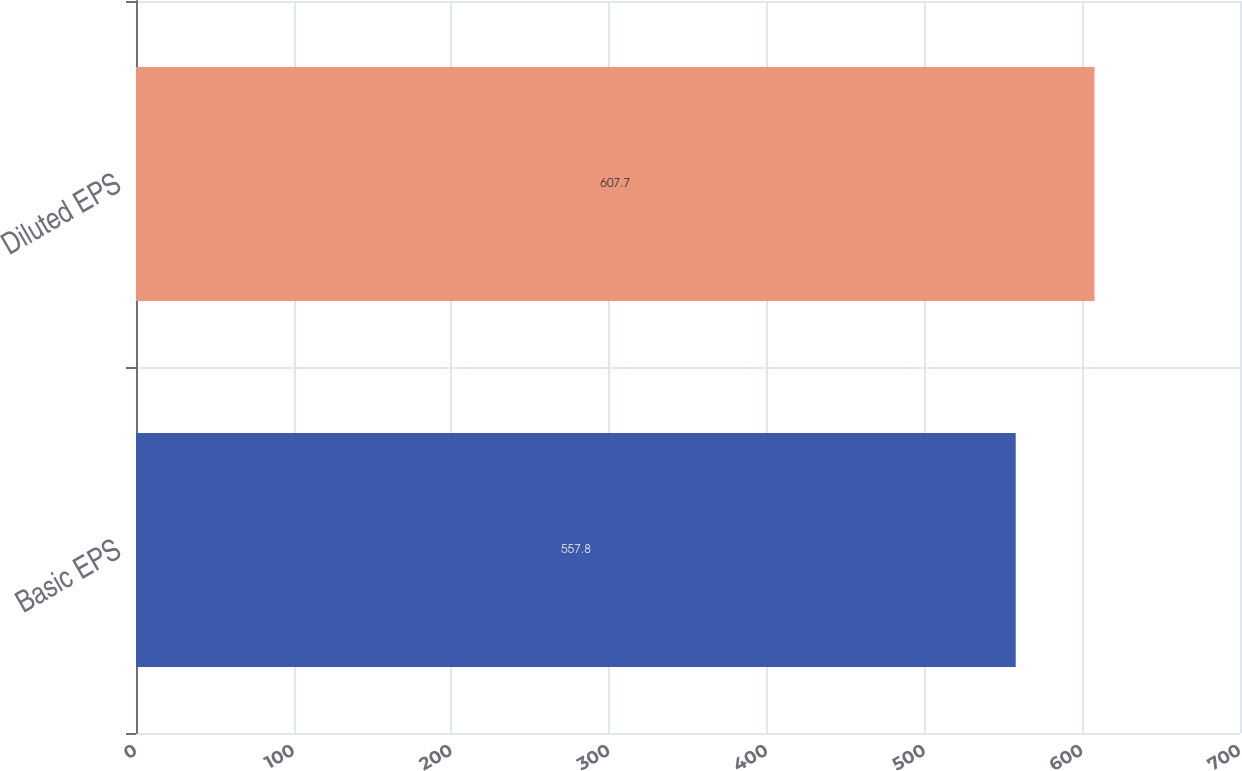Convert chart to OTSL. <chart><loc_0><loc_0><loc_500><loc_500><bar_chart><fcel>Basic EPS<fcel>Diluted EPS<nl><fcel>557.8<fcel>607.7<nl></chart> 